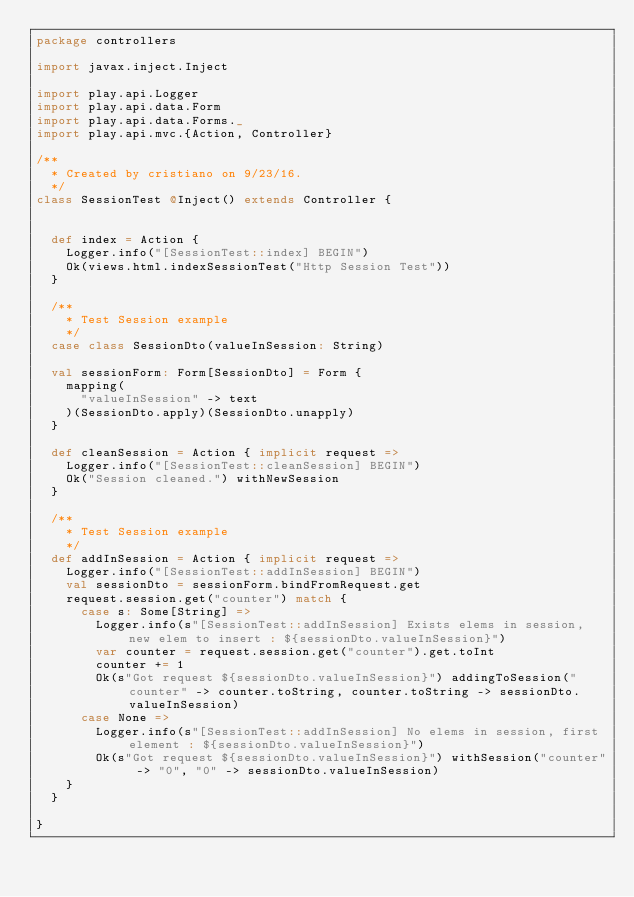Convert code to text. <code><loc_0><loc_0><loc_500><loc_500><_Scala_>package controllers

import javax.inject.Inject

import play.api.Logger
import play.api.data.Form
import play.api.data.Forms._
import play.api.mvc.{Action, Controller}

/**
  * Created by cristiano on 9/23/16.
  */
class SessionTest @Inject() extends Controller {


  def index = Action {
    Logger.info("[SessionTest::index] BEGIN")
    Ok(views.html.indexSessionTest("Http Session Test"))
  }

  /**
    * Test Session example
    */
  case class SessionDto(valueInSession: String)

  val sessionForm: Form[SessionDto] = Form {
    mapping(
      "valueInSession" -> text
    )(SessionDto.apply)(SessionDto.unapply)
  }

  def cleanSession = Action { implicit request =>
    Logger.info("[SessionTest::cleanSession] BEGIN")
    Ok("Session cleaned.") withNewSession
  }

  /**
    * Test Session example
    */
  def addInSession = Action { implicit request =>
    Logger.info("[SessionTest::addInSession] BEGIN")
    val sessionDto = sessionForm.bindFromRequest.get
    request.session.get("counter") match {
      case s: Some[String] =>
        Logger.info(s"[SessionTest::addInSession] Exists elems in session, new elem to insert : ${sessionDto.valueInSession}")
        var counter = request.session.get("counter").get.toInt
        counter += 1
        Ok(s"Got request ${sessionDto.valueInSession}") addingToSession("counter" -> counter.toString, counter.toString -> sessionDto.valueInSession)
      case None =>
        Logger.info(s"[SessionTest::addInSession] No elems in session, first element : ${sessionDto.valueInSession}")
        Ok(s"Got request ${sessionDto.valueInSession}") withSession("counter" -> "0", "0" -> sessionDto.valueInSession)
    }
  }

}
</code> 